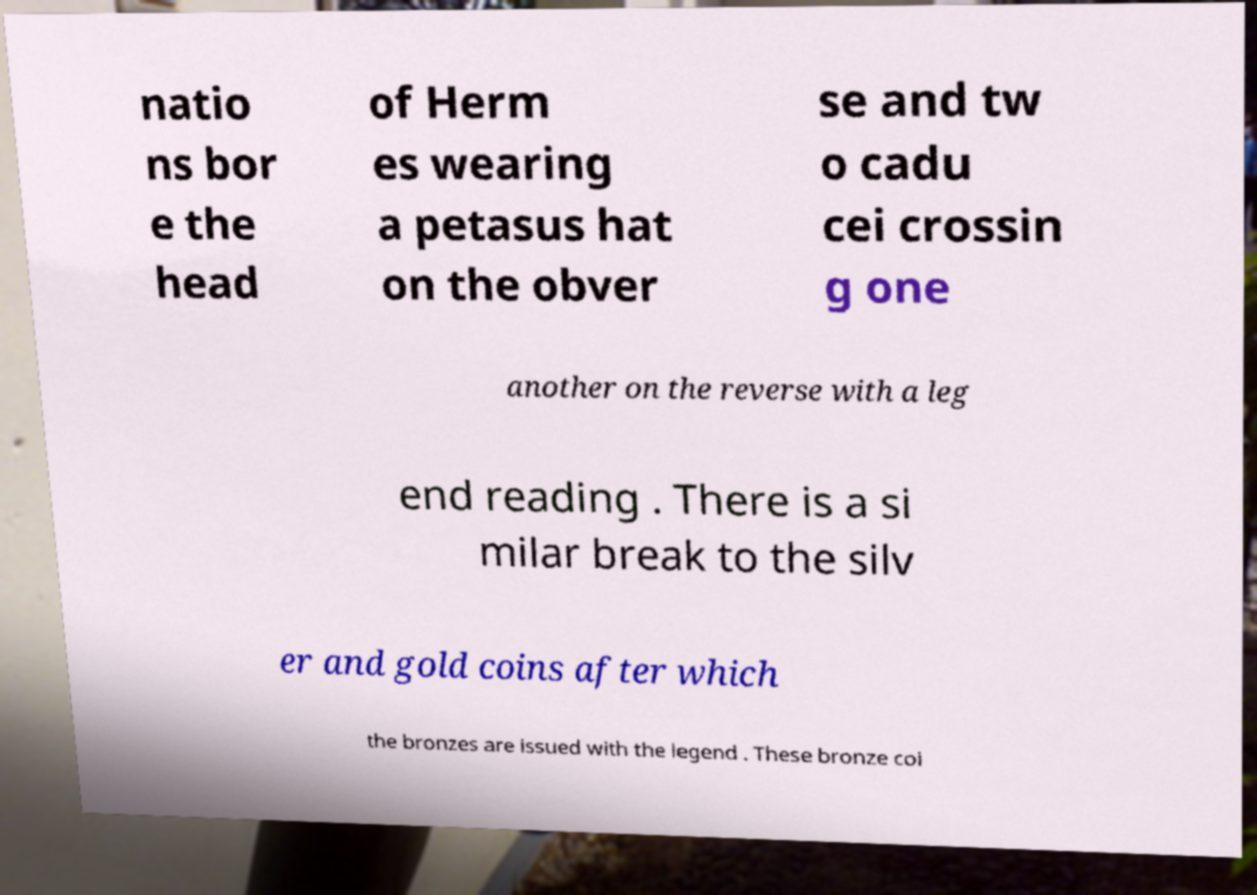Please identify and transcribe the text found in this image. natio ns bor e the head of Herm es wearing a petasus hat on the obver se and tw o cadu cei crossin g one another on the reverse with a leg end reading . There is a si milar break to the silv er and gold coins after which the bronzes are issued with the legend . These bronze coi 